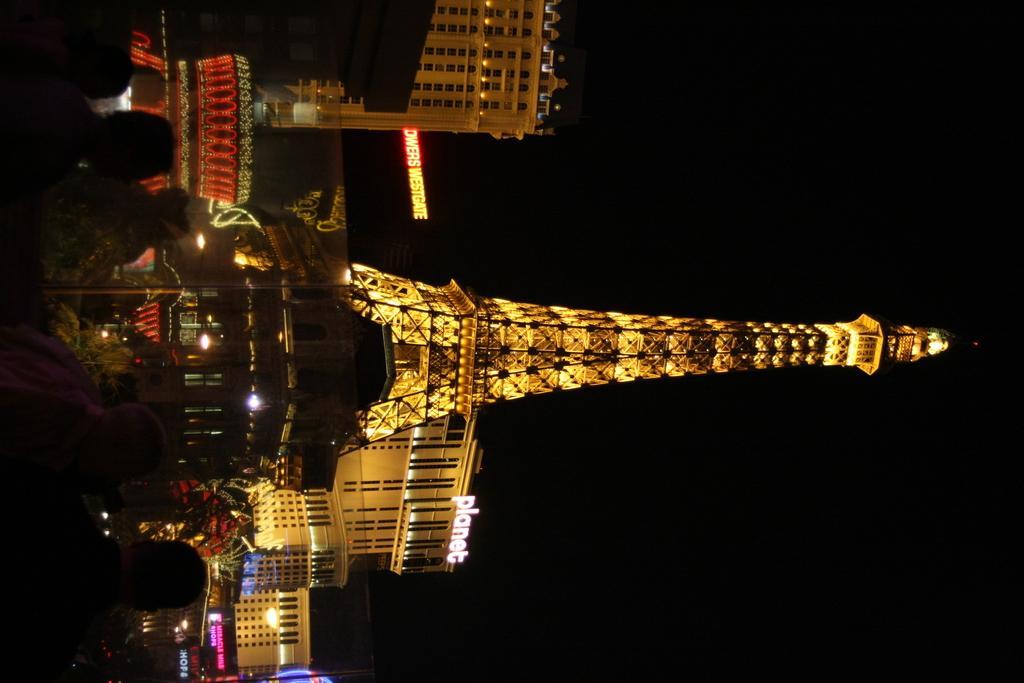Can you describe this image briefly? In this image I can see few people and I can see the tower, buildings and the boards. I can see the black background. 